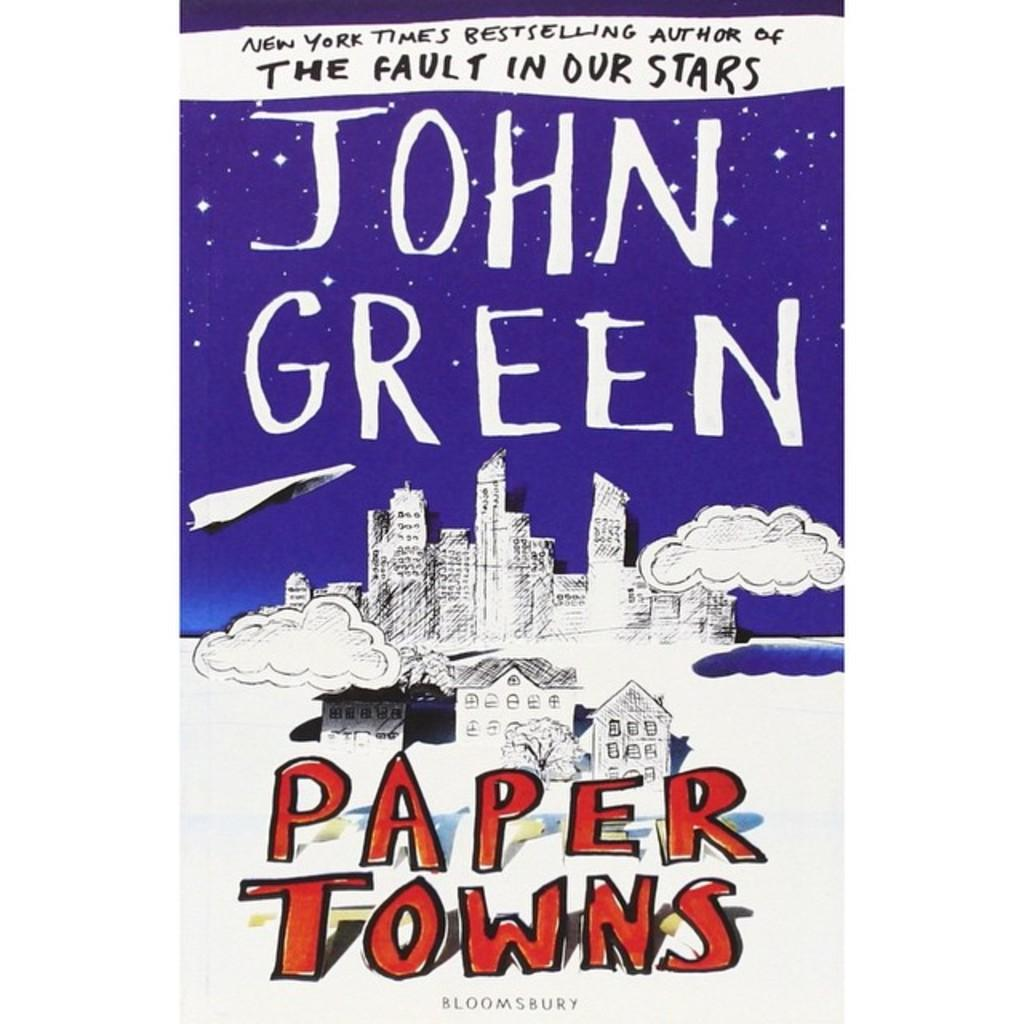<image>
Present a compact description of the photo's key features. The book Paper Towns written by John Green, who also wrote The Fault in Our Stars. 